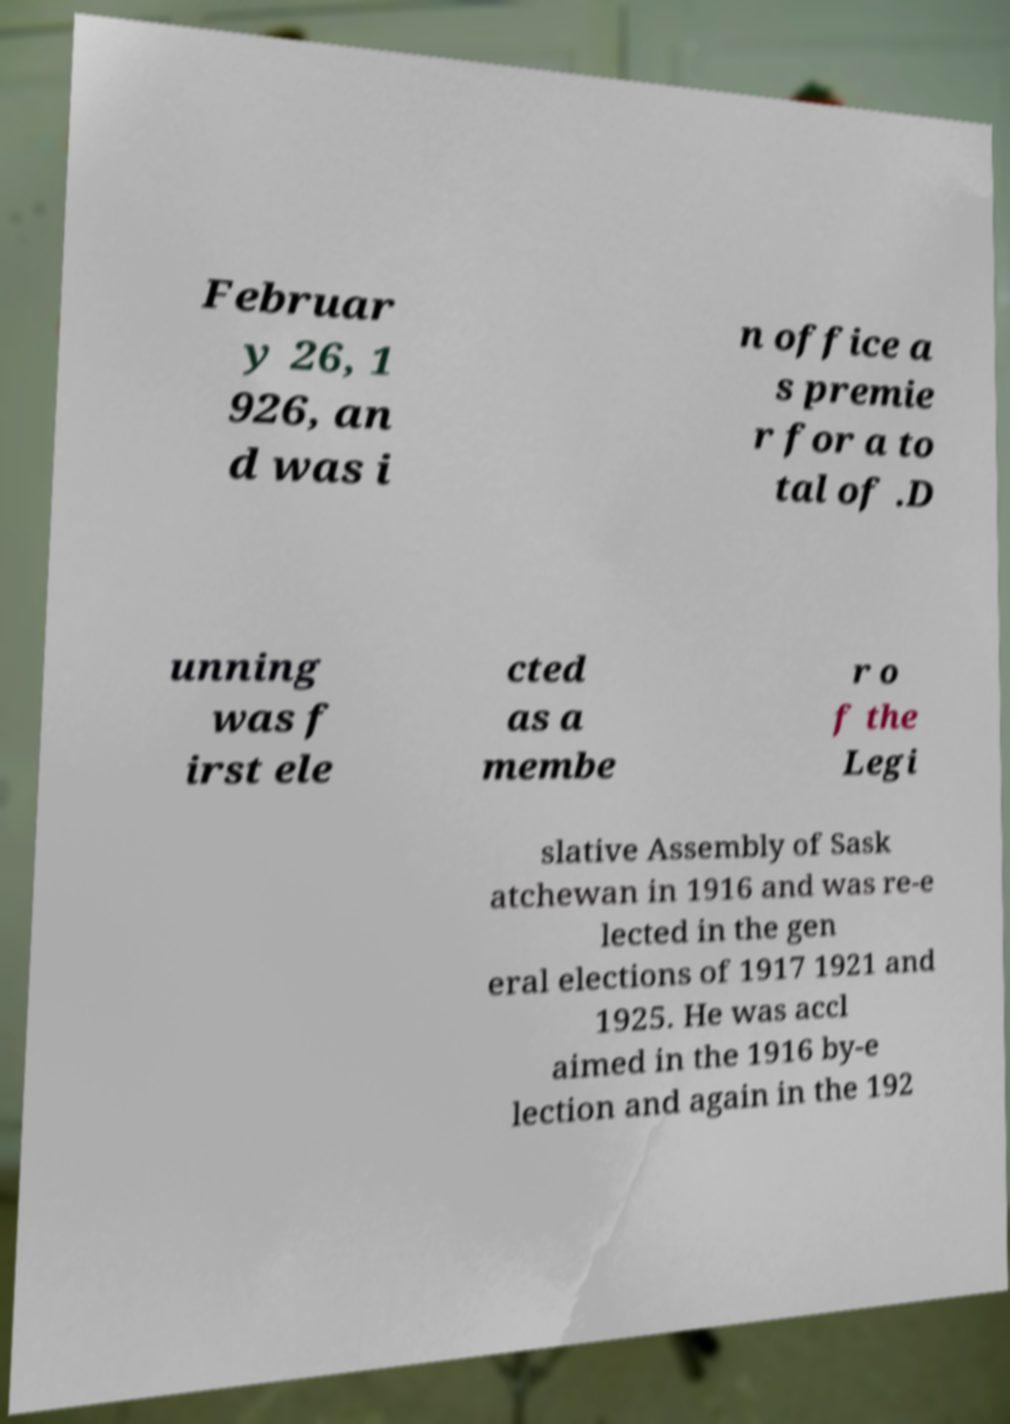Please read and relay the text visible in this image. What does it say? Februar y 26, 1 926, an d was i n office a s premie r for a to tal of .D unning was f irst ele cted as a membe r o f the Legi slative Assembly of Sask atchewan in 1916 and was re-e lected in the gen eral elections of 1917 1921 and 1925. He was accl aimed in the 1916 by-e lection and again in the 192 